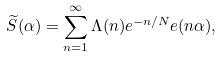Convert formula to latex. <formula><loc_0><loc_0><loc_500><loc_500>\widetilde { S } ( \alpha ) = \sum _ { n = 1 } ^ { \infty } \Lambda ( n ) e ^ { - n / N } e ( n \alpha ) ,</formula> 